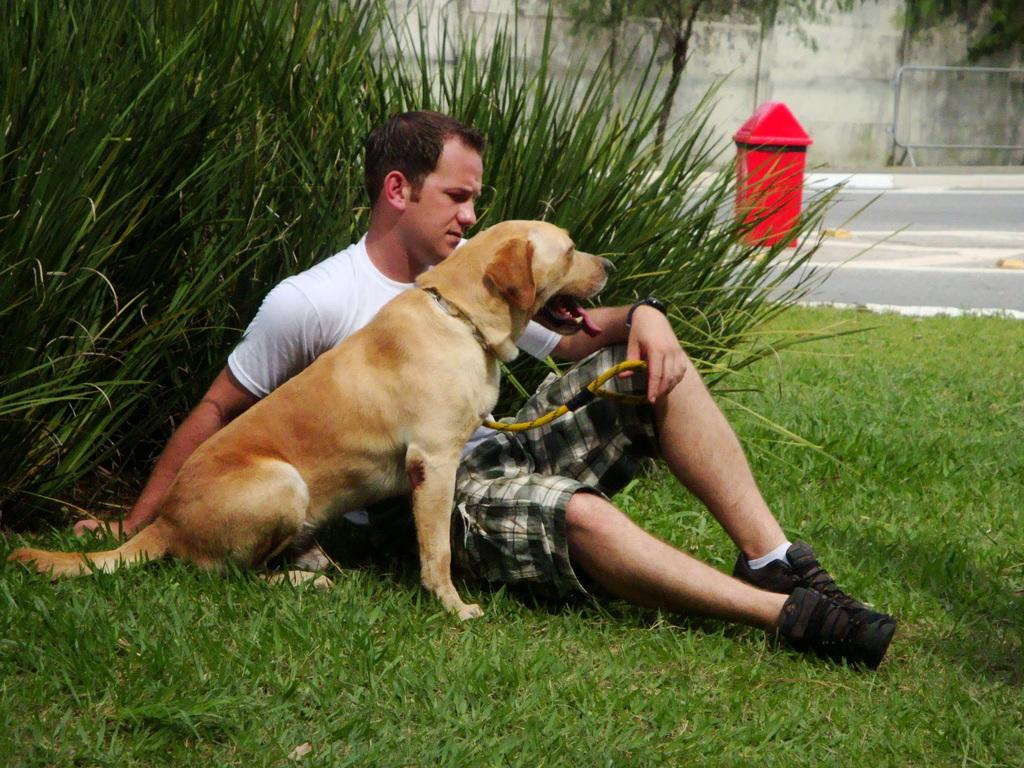What is the person in the image doing? The person is sitting on the grass. What is in front of the person? There is a dog in front of the person. What can be seen behind the person? There are plants and a red color bin behind the person. Can you hear the person in the image coughing? There is no sound in the image, so it is not possible to determine if the person is coughing or not. 